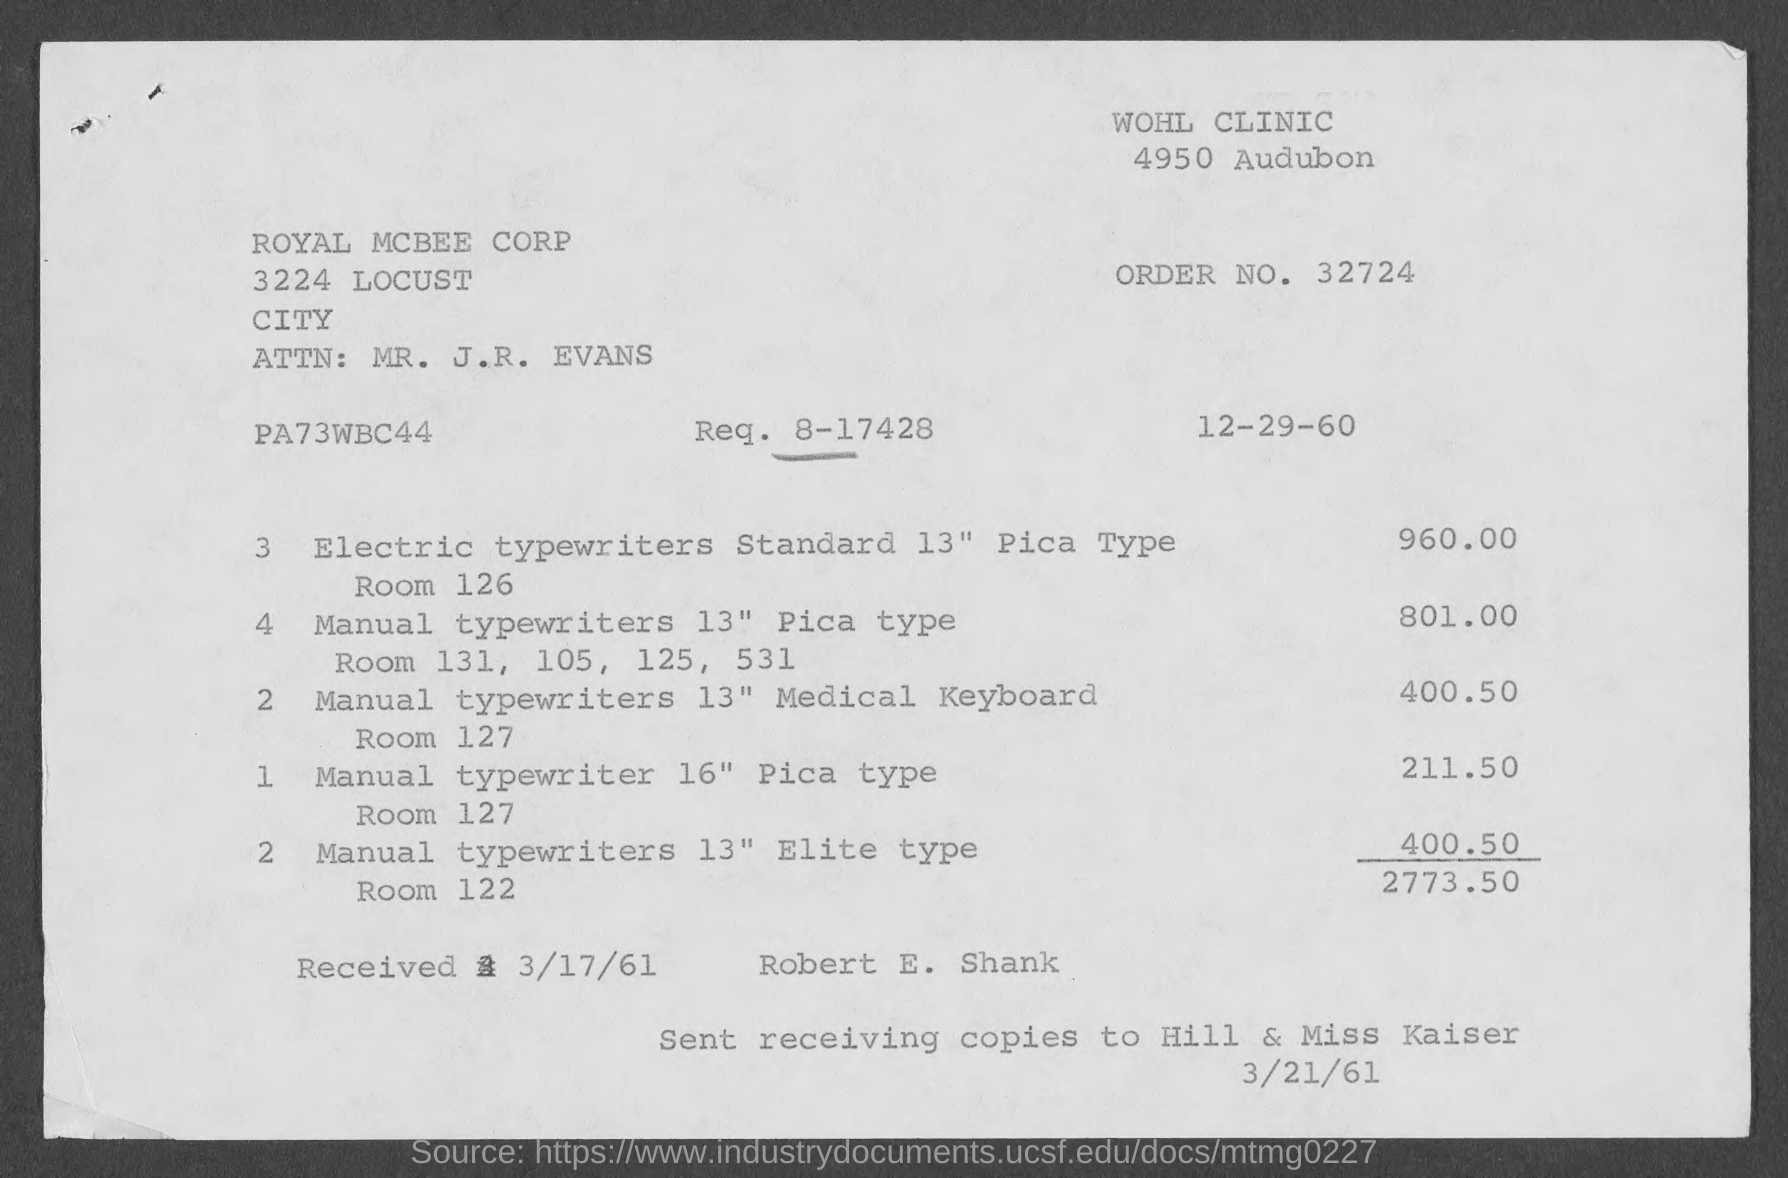How many typewriters were ordered in total according to this invoice? According to the invoice, a total of 12 typewriters were ordered. The breakdown includes 3 electric typewriters and 9 manual typewriters of various types. 